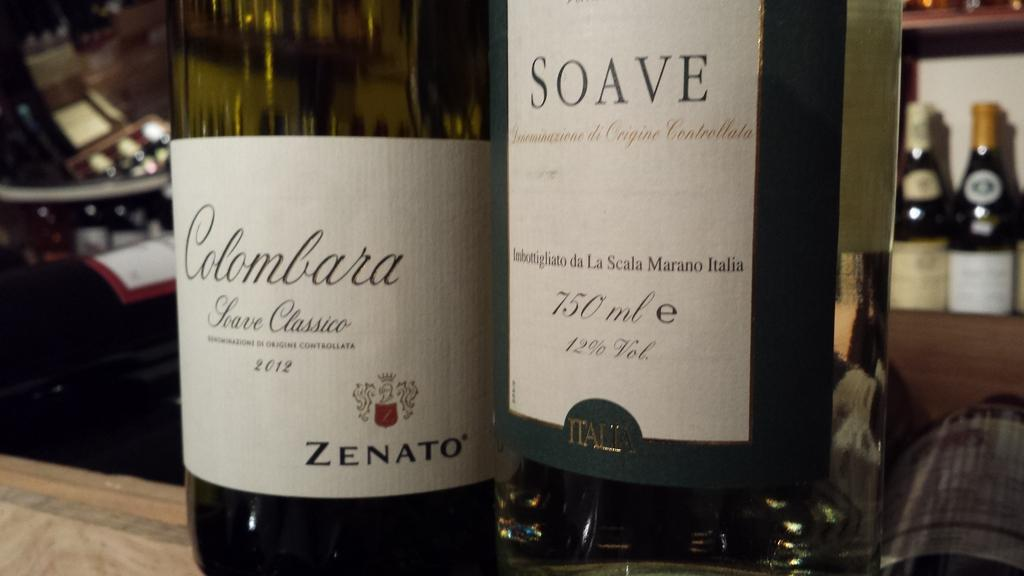Provide a one-sentence caption for the provided image. Two bottles of wine called Colombara and Soave sit on a counter. 